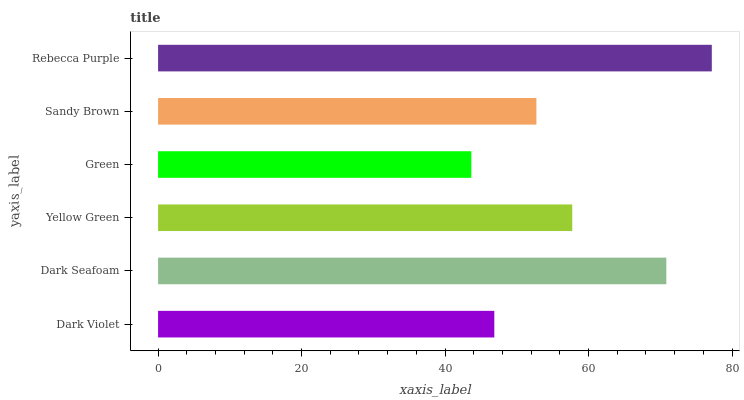Is Green the minimum?
Answer yes or no. Yes. Is Rebecca Purple the maximum?
Answer yes or no. Yes. Is Dark Seafoam the minimum?
Answer yes or no. No. Is Dark Seafoam the maximum?
Answer yes or no. No. Is Dark Seafoam greater than Dark Violet?
Answer yes or no. Yes. Is Dark Violet less than Dark Seafoam?
Answer yes or no. Yes. Is Dark Violet greater than Dark Seafoam?
Answer yes or no. No. Is Dark Seafoam less than Dark Violet?
Answer yes or no. No. Is Yellow Green the high median?
Answer yes or no. Yes. Is Sandy Brown the low median?
Answer yes or no. Yes. Is Sandy Brown the high median?
Answer yes or no. No. Is Dark Violet the low median?
Answer yes or no. No. 